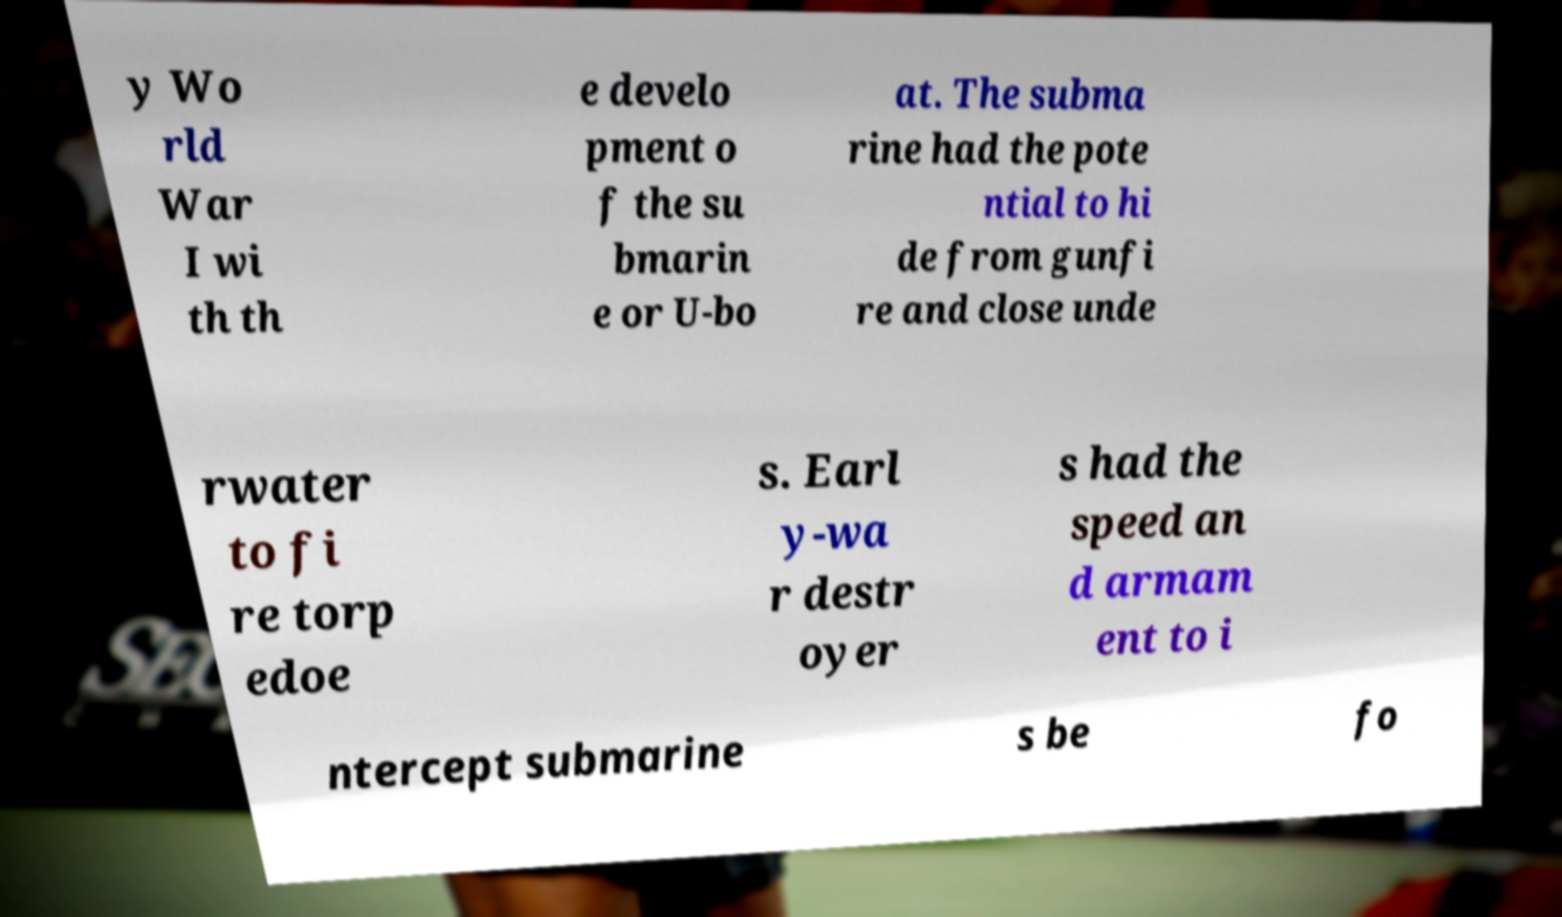I need the written content from this picture converted into text. Can you do that? y Wo rld War I wi th th e develo pment o f the su bmarin e or U-bo at. The subma rine had the pote ntial to hi de from gunfi re and close unde rwater to fi re torp edoe s. Earl y-wa r destr oyer s had the speed an d armam ent to i ntercept submarine s be fo 